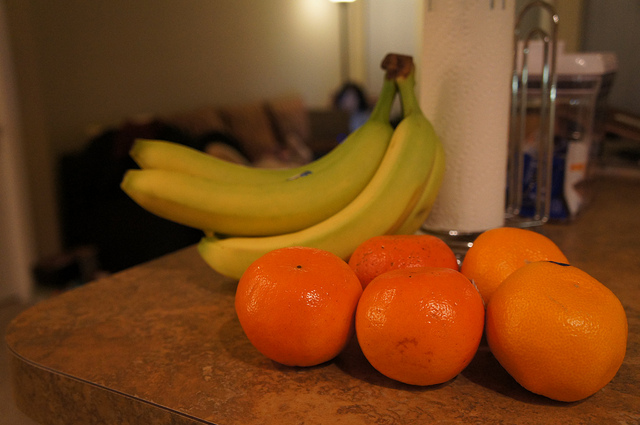<image>What kind of vegetables are the color orange? It is ambiguous to identify what kind of vegetables are the color orange since it can include squash, carrots or even oranges, although oranges are technically classified as a fruit. What kind of vegetables are the color orange? I don't know what kind of vegetables are the color orange. It can be carrots or squash. 